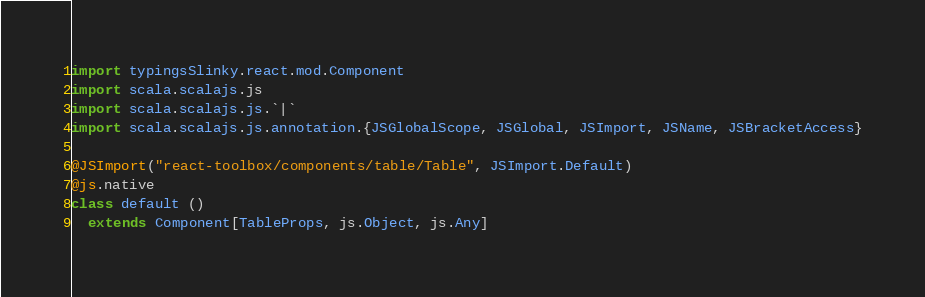Convert code to text. <code><loc_0><loc_0><loc_500><loc_500><_Scala_>
import typingsSlinky.react.mod.Component
import scala.scalajs.js
import scala.scalajs.js.`|`
import scala.scalajs.js.annotation.{JSGlobalScope, JSGlobal, JSImport, JSName, JSBracketAccess}

@JSImport("react-toolbox/components/table/Table", JSImport.Default)
@js.native
class default ()
  extends Component[TableProps, js.Object, js.Any]
</code> 